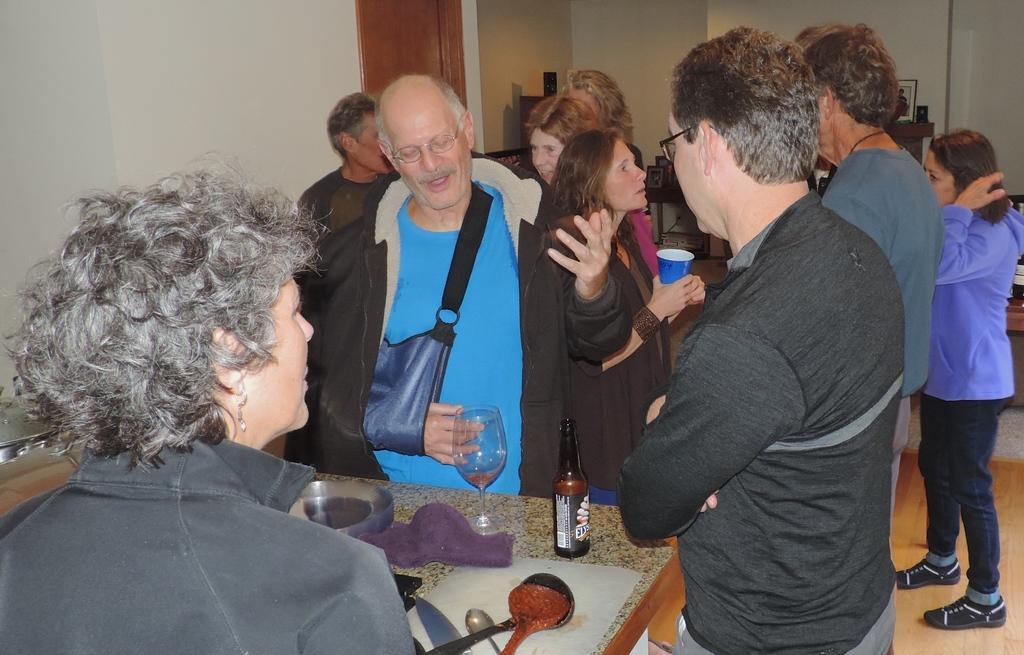Could you give a brief overview of what you see in this image? In this picture we can see a group of men and women discussing something. In front there is a table on which spoons, glass and a beer bottle is placed. In front of the image we can see a old woman wearing black jacket listening to them. In the background you can see white color wall and a wooden door. 